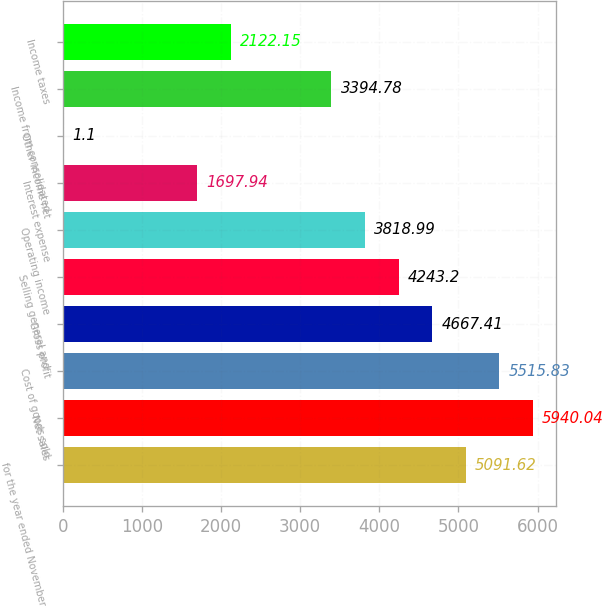Convert chart to OTSL. <chart><loc_0><loc_0><loc_500><loc_500><bar_chart><fcel>for the year ended November 30<fcel>Net sales<fcel>Cost of goods sold<fcel>Gross profit<fcel>Selling general and<fcel>Operating income<fcel>Interest expense<fcel>Other income net<fcel>Income from consolidated<fcel>Income taxes<nl><fcel>5091.62<fcel>5940.04<fcel>5515.83<fcel>4667.41<fcel>4243.2<fcel>3818.99<fcel>1697.94<fcel>1.1<fcel>3394.78<fcel>2122.15<nl></chart> 